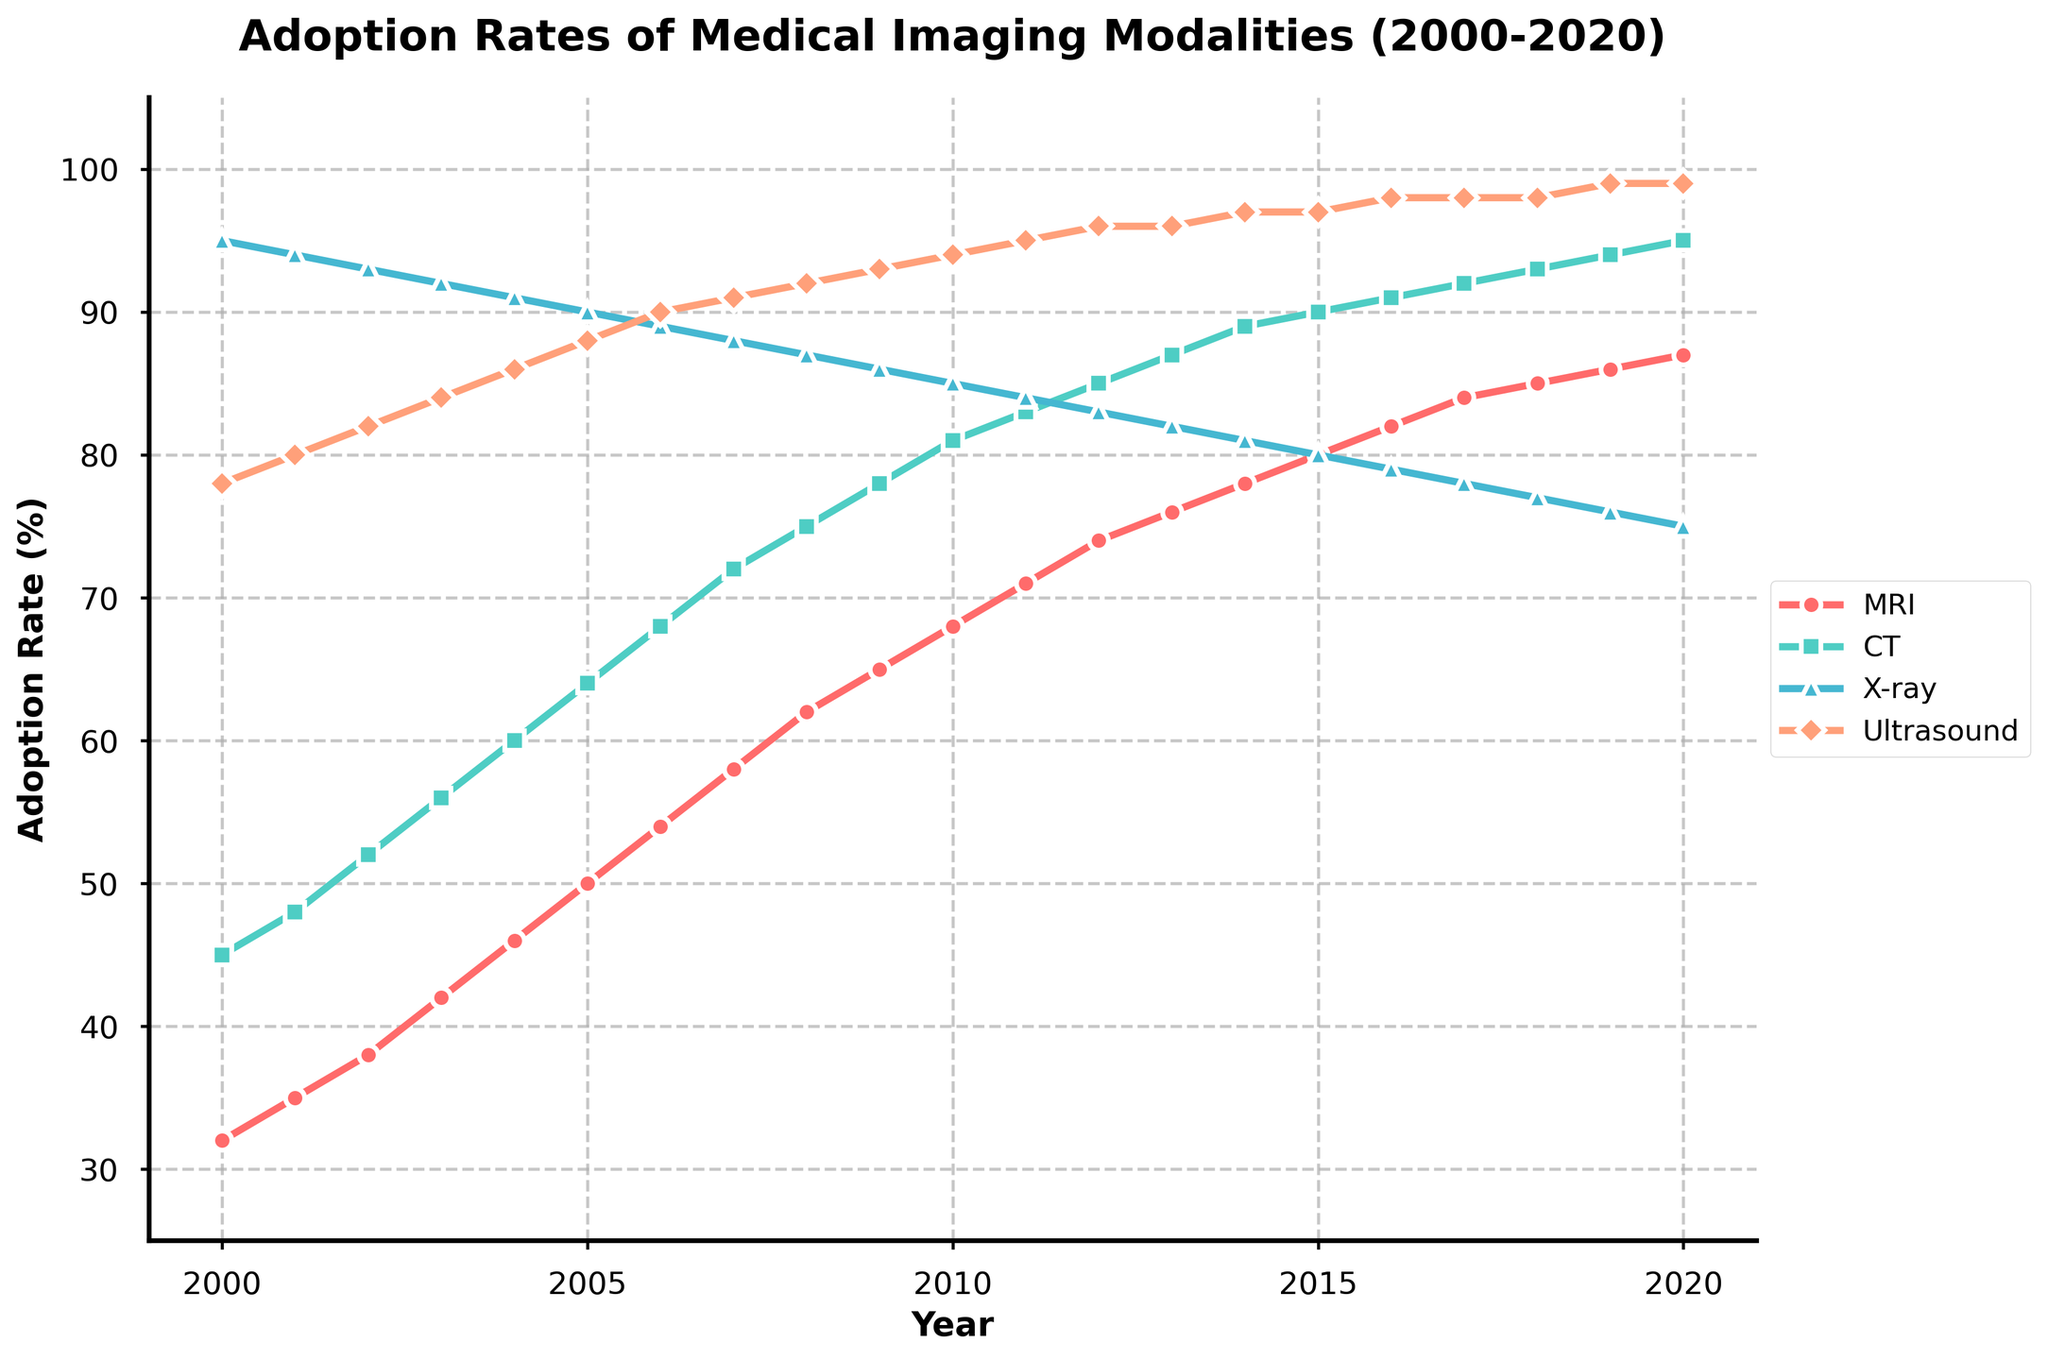What year did MRI adoption rates surpass 50%? Examine the MRI adoption rates along the timeline. Notice that in 2005, the MRI adoption rate is 50%, and it surpasses this value in 2006 with 54%.
Answer: 2006 Which imaging modality had the highest adoption rate in the year 2015? Look at the adoption rates for all modalities in 2015. Ultrasound has the highest adoption rate at 97%.
Answer: Ultrasound Between which two consecutive years did the CT adoption rate increase the most? Calculate the year-over-year differences for CT adoption rates. The largest increase is from 2001 to 2002, going from 48% to 52%, a difference of 4%.
Answer: 2001 to 2002 What is the overall trend in adoption rates for X-ray from 2000 to 2020? Observe the X-ray adoption rate over the years. It shows a declining trend, starting from 95% in 2000 and decreasing to 75% in 2020.
Answer: Declining In which years did Ultrasound adoption rates remain constant? Check the years where Ultrasound adoption rates did not change. The rates remained constant from 2013 to 2014 (96%) and from 2015 to 2017 (97%), and from 2018 to 2020 (98-99%).
Answer: 2013-2014, 2015-2017, 2018-2020 How many years did it take for MRI adoption rates to double from their value in 2000? Identify the MRI adoption rate in 2000 (32%). Double this value is 64%. MRI adoption rates reached 65% in 2009, which is 9 years after 2000.
Answer: 9 years Which imaging modality had the smallest change in adoption rate between 2000 and 2020? Calculate the difference for each modality from 2000 to 2020. X-ray has the smallest change, decreasing from 95% to 75%, a change of 20%.
Answer: X-ray What is the average adoption rate of CT over the entire period? Sum all CT adoption rates from 2000 to 2020 and divide by the number of years (21). (45+48+52+56+60+64+68+72+75+78+81+83+85+87+89+90+91+92+93+94+95)/21 = 74.238
Answer: 74.2% In 2020, how much higher was the adoption rate of MRI compared to that of X-ray? Subtract X-ray's adoption rate in 2020 (75%) from MRI's adoption rate in 2020 (87%). 87% - 75% = 12%
Answer: 12% Which modality's adoption rate line has the steepest initial increase? Compare the initial slopes of the lines for different modalities. MRI's adoption rate rises from 32% to 42% between 2000 and 2003, a steep increase compared to others.
Answer: MRI 